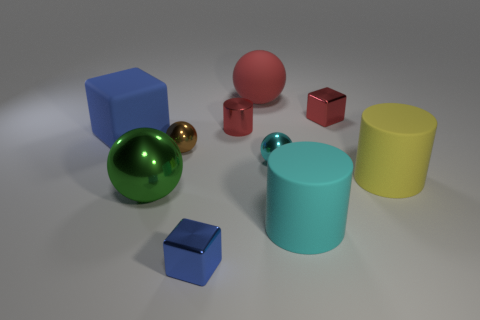Subtract all cylinders. How many objects are left? 7 Subtract all tiny brown shiny spheres. How many spheres are left? 3 Subtract 1 cylinders. How many cylinders are left? 2 Subtract all big yellow matte cylinders. Subtract all cyan rubber cylinders. How many objects are left? 8 Add 3 tiny blue objects. How many tiny blue objects are left? 4 Add 9 cyan metal balls. How many cyan metal balls exist? 10 Subtract all blue cubes. How many cubes are left? 1 Subtract 1 brown balls. How many objects are left? 9 Subtract all brown cylinders. Subtract all cyan balls. How many cylinders are left? 3 Subtract all red balls. How many yellow cylinders are left? 1 